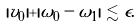Convert formula to latex. <formula><loc_0><loc_0><loc_500><loc_500>& | v _ { 0 } | + | \omega _ { 0 } - \omega _ { 1 } | \lesssim \epsilon .</formula> 